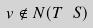Convert formula to latex. <formula><loc_0><loc_0><loc_500><loc_500>v \notin N ( T \ S )</formula> 